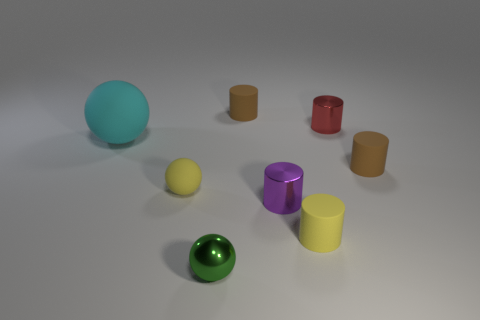Subtract all tiny matte balls. How many balls are left? 2 Subtract all purple cylinders. How many cylinders are left? 4 Add 2 large purple objects. How many objects exist? 10 Subtract all spheres. How many objects are left? 5 Subtract 3 spheres. How many spheres are left? 0 Subtract 0 blue cubes. How many objects are left? 8 Subtract all purple cylinders. Subtract all brown balls. How many cylinders are left? 4 Subtract all green cubes. How many red cylinders are left? 1 Subtract all tiny green metal balls. Subtract all big cyan balls. How many objects are left? 6 Add 4 red metal objects. How many red metal objects are left? 5 